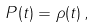Convert formula to latex. <formula><loc_0><loc_0><loc_500><loc_500>P ( t ) = \rho ( t ) \, ,</formula> 